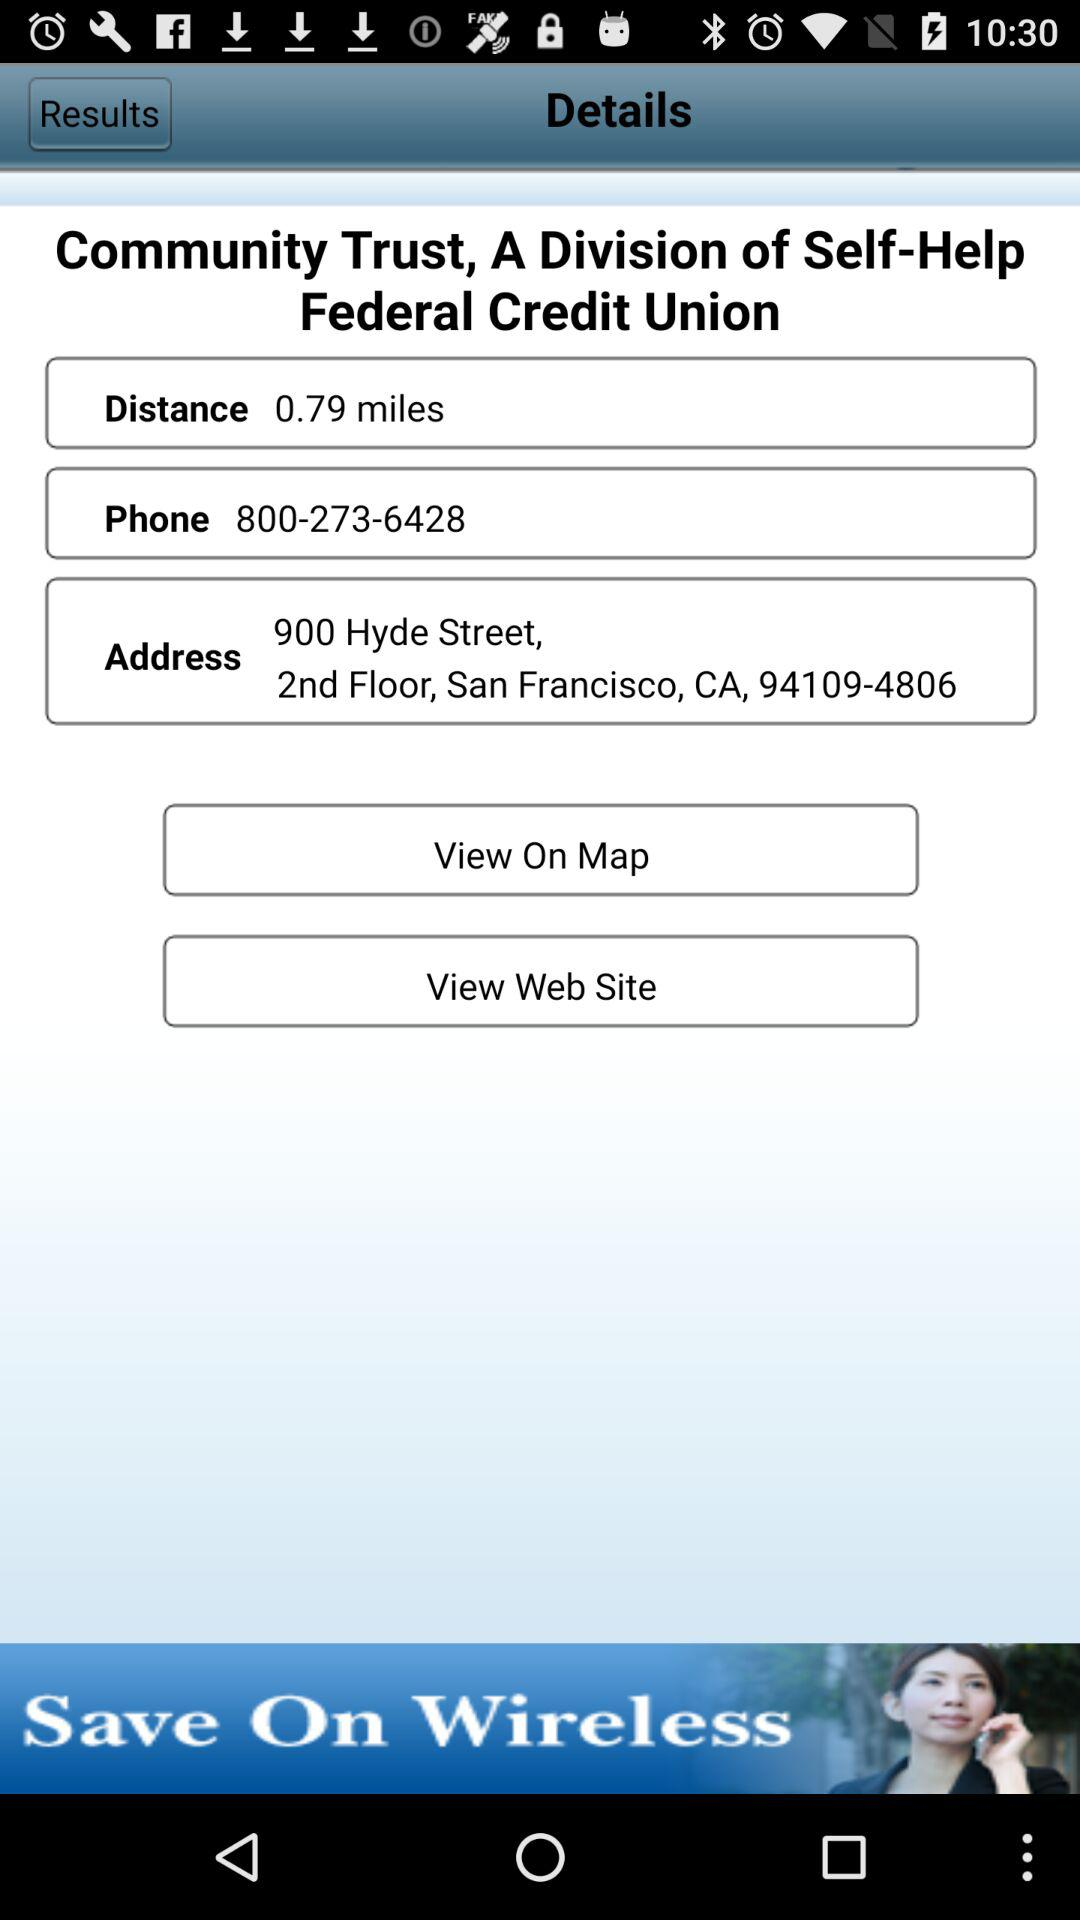How much is the distance? The distance is 0.79 miles. 